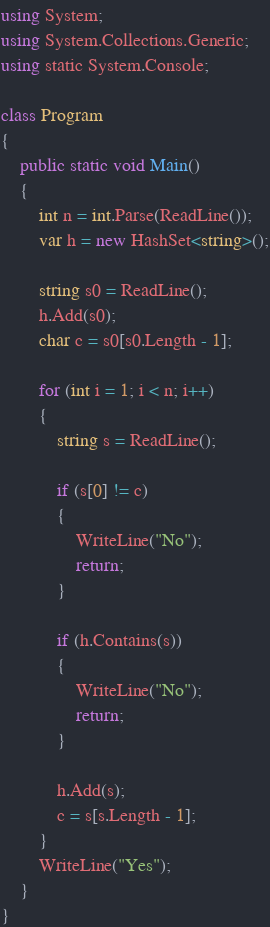<code> <loc_0><loc_0><loc_500><loc_500><_C#_>
using System;
using System.Collections.Generic;
using static System.Console;

class Program
{
    public static void Main()
    {
        int n = int.Parse(ReadLine());
        var h = new HashSet<string>();

        string s0 = ReadLine();
        h.Add(s0);
        char c = s0[s0.Length - 1];

        for (int i = 1; i < n; i++)
        {
            string s = ReadLine();

            if (s[0] != c)
            {
                WriteLine("No");
                return;
            }

            if (h.Contains(s))
            {
                WriteLine("No");
                return;
            }

            h.Add(s);
            c = s[s.Length - 1];
        }
        WriteLine("Yes");
    }
}
</code> 